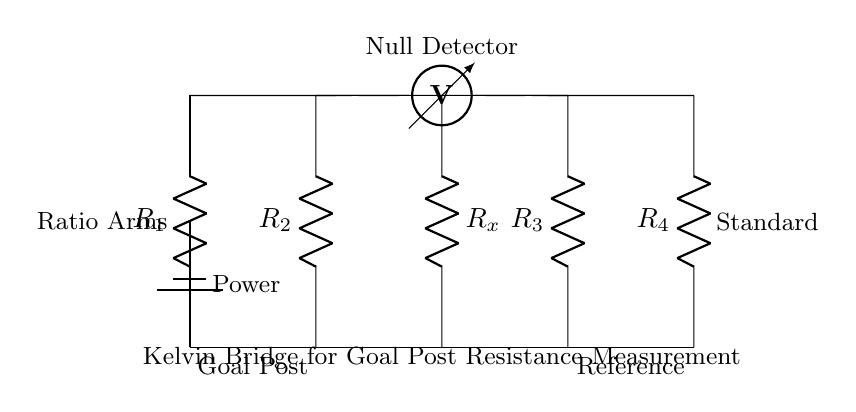What type of circuit is this? This circuit is classified as a Kelvin bridge, which is specifically designed for measuring low resistances with high precision. The arrangement helps to eliminate the effects of lead and contact resistances.
Answer: Kelvin bridge What is the role of the voltmeter in this circuit? The voltmeter is connected across the two points where the null condition is to be detected. It measures the potential difference, indicating when the bridge is balanced and the ratio of resistances is equal.
Answer: Measure potential difference Which component represents the unknown resistance in the circuit? The unknown resistance is denoted as R_x, which is located in the middle of the circuit and is the resistance to be measured.
Answer: R_x What is the purpose of the power source in this circuit? The power source supplies the necessary voltage for the circuit, enabling current flow through the resistances and allowing measurements to be made.
Answer: Supply voltage How many resistors are in this circuit? There are four resistors labeled as R_1, R_2, R_3, and R_4, along with one unknown resistance R_x.
Answer: Five resistors What is meant by the term "null detector" in this circuit? The null detector is used to determine the point at which the bridge is balanced, signifying that the ratio of the resistances is equal and indicating that there is no potential difference across it.
Answer: Determine balance point What do the labels "Goal Post" and "Reference" signify in this diagram? "Goal Post" refers to one side of the circuit where the unknown resistance (possibly of an actual goal post in context) is measured, while "Reference" refers to the standard resistance used for comparison and balancing.
Answer: Measurement locations 